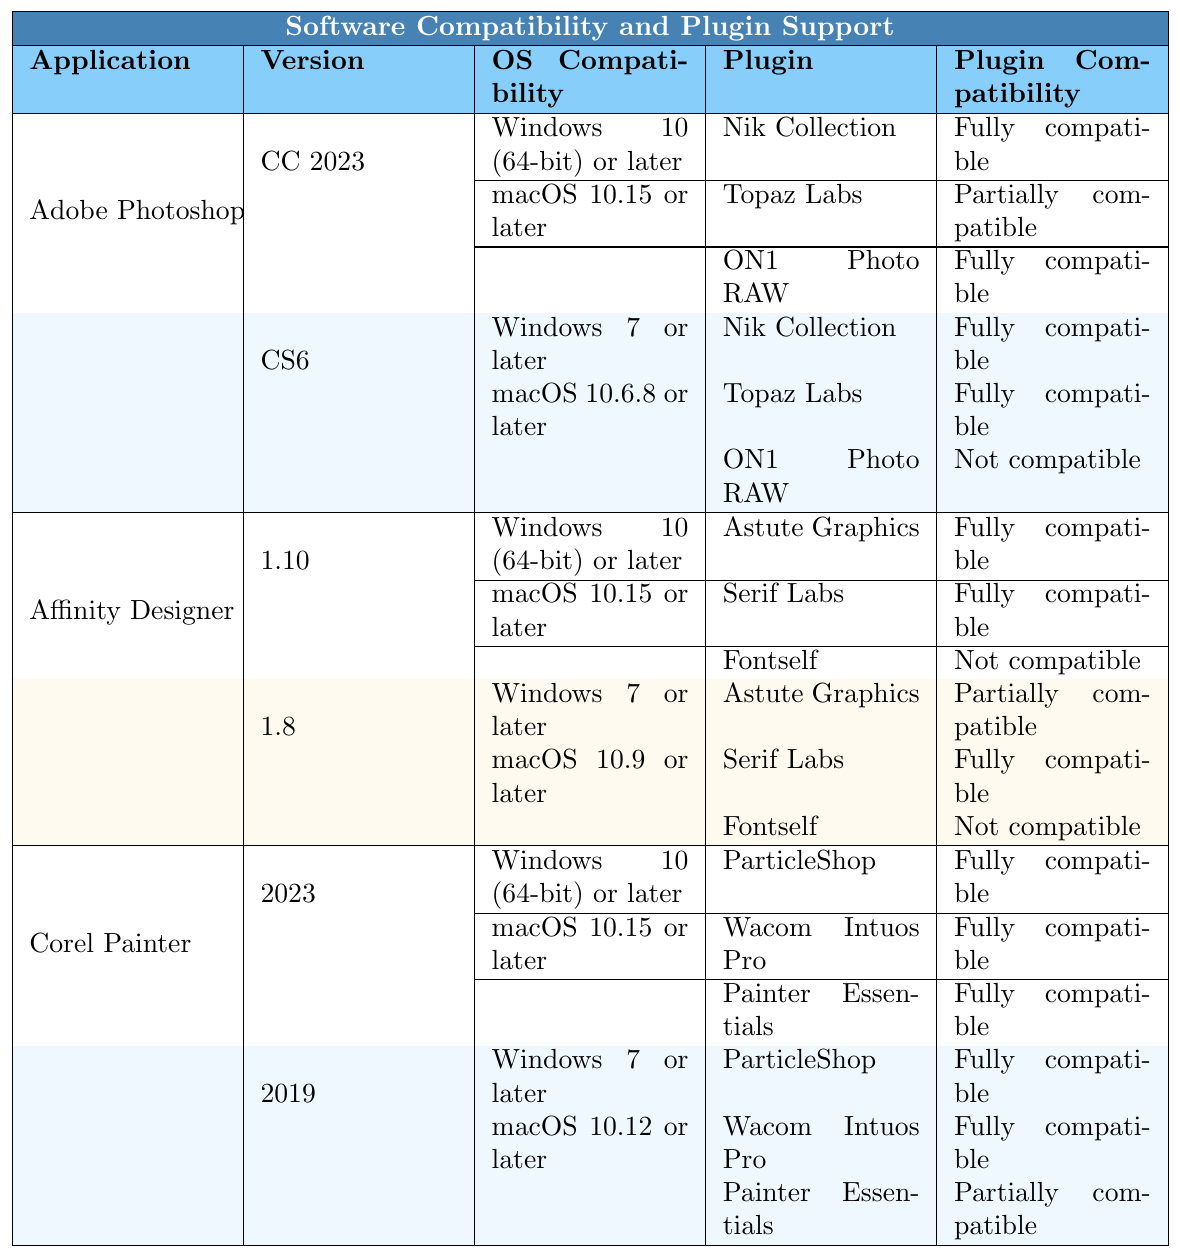What is the OS compatibility for Adobe Photoshop CC 2023? The table shows that Adobe Photoshop CC 2023 is compatible with Windows 10 (64-bit) or later, and macOS 10.15 or later.
Answer: Windows 10 (64-bit) or later, macOS 10.15 or later Which plugin is not compatible with Adobe Photoshop CS6? According to the table, ON1 Photo RAW is not compatible with Adobe Photoshop CS6.
Answer: ON1 Photo RAW How many plugins are fully compatible with Corel Painter 2023? The table lists three plugins for Corel Painter 2023, all of which—ParticleShop, Wacom Intuos Pro, and Painter Essentials—are fully compatible.
Answer: 3 Is Affinity Designer 1.8 compatible with the Fontself plugin? The table indicates that the Fontself plugin is not compatible with Affinity Designer 1.8.
Answer: No What is the difference in the number of fully compatible plugins between Adobe Photoshop CS6 and Corel Painter 2019? Adobe Photoshop CS6 has two fully compatible plugins (Nik Collection and Topaz Labs), while Corel Painter 2019 has two fully compatible plugins (ParticleShop and Wacom Intuos Pro). Therefore, the difference is 2 - 2 = 0.
Answer: 0 Which version of Affinity Designer has a partially compatible plugin? The table states that Affinity Designer 1.8 has the Astute Graphics plugin that is partially compatible.
Answer: Affinity Designer 1.8 Does Corel Painter 2019 support Painter Essentials fully? The table shows that Painter Essentials is only partially compatible with Corel Painter 2019.
Answer: No How many plugins are listed for Adobe Photoshop CC 2023, and how many of them are fully compatible? Adobe Photoshop CC 2023 has three plugins listed (Nik Collection, Topaz Labs, and ON1 Photo RAW), of which two (Nik Collection and ON1 Photo RAW) are fully compatible.
Answer: 3 plugins, 2 fully compatible Can Affinity Designer 1.10 use the Fontself plugin? The table shows that the Fontself plugin is not compatible with Affinity Designer 1.10.
Answer: No What are the OS compatibility requirements for Corel Painter 2023? The table states that Corel Painter 2023 is compatible with Windows 10 (64-bit) or later and macOS 10.15 or later.
Answer: Windows 10 (64-bit) or later, macOS 10.15 or later 